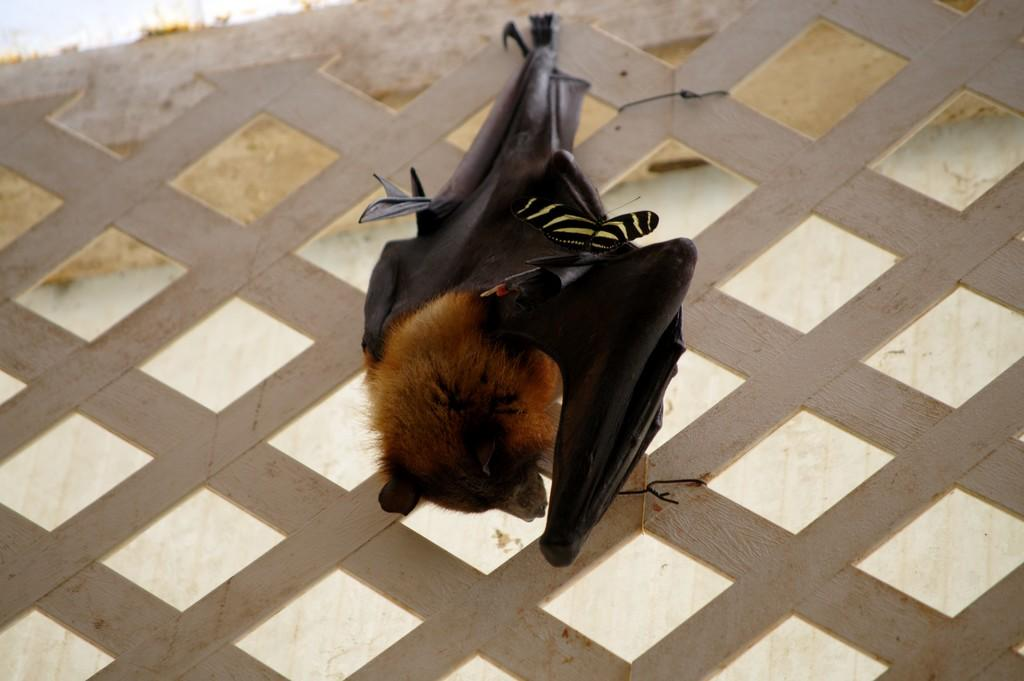What type of animal is present in the image? The image features a bird on an animal. Can you describe the bird in the image? Unfortunately, the facts provided do not give any details about the bird's appearance or characteristics. What is the relationship between the bird and the animal in the image? The bird is on the animal, but the nature of their interaction or relationship is not specified in the facts. What note is the bird singing in the image? There is no information about the bird singing or producing any sound in the image. What type of growth can be observed on the animal in the image? The facts provided do not mention any growth or physical characteristics of the animal. 